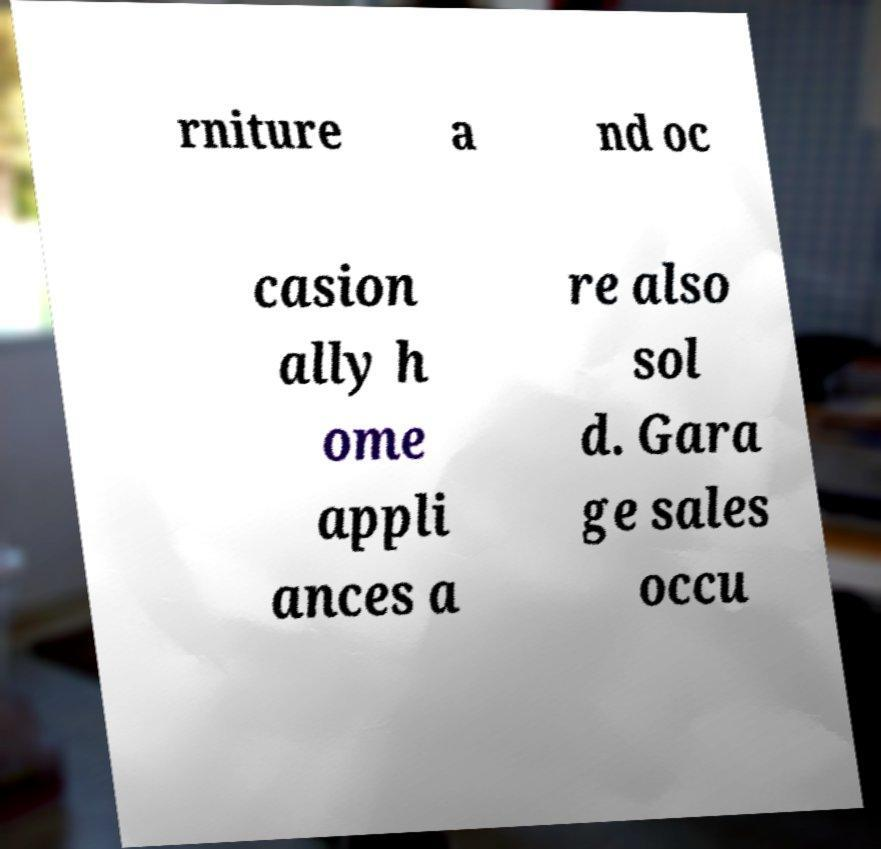Could you assist in decoding the text presented in this image and type it out clearly? rniture a nd oc casion ally h ome appli ances a re also sol d. Gara ge sales occu 